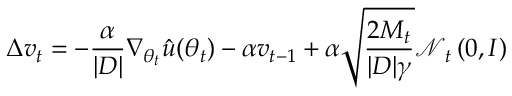<formula> <loc_0><loc_0><loc_500><loc_500>\Delta v _ { t } = - \frac { \alpha } { | D | } \nabla _ { \theta _ { t } } \hat { u } ( \theta _ { t } ) - \alpha v _ { t - 1 } + \alpha \sqrt { \frac { 2 M _ { t } } { | D | \gamma } } \mathcal { N } _ { t } \left ( 0 , I \right )</formula> 